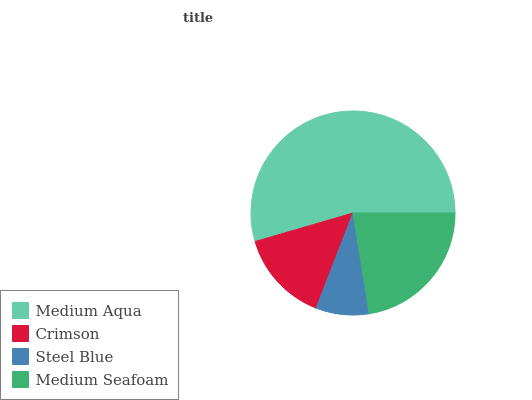Is Steel Blue the minimum?
Answer yes or no. Yes. Is Medium Aqua the maximum?
Answer yes or no. Yes. Is Crimson the minimum?
Answer yes or no. No. Is Crimson the maximum?
Answer yes or no. No. Is Medium Aqua greater than Crimson?
Answer yes or no. Yes. Is Crimson less than Medium Aqua?
Answer yes or no. Yes. Is Crimson greater than Medium Aqua?
Answer yes or no. No. Is Medium Aqua less than Crimson?
Answer yes or no. No. Is Medium Seafoam the high median?
Answer yes or no. Yes. Is Crimson the low median?
Answer yes or no. Yes. Is Steel Blue the high median?
Answer yes or no. No. Is Medium Aqua the low median?
Answer yes or no. No. 